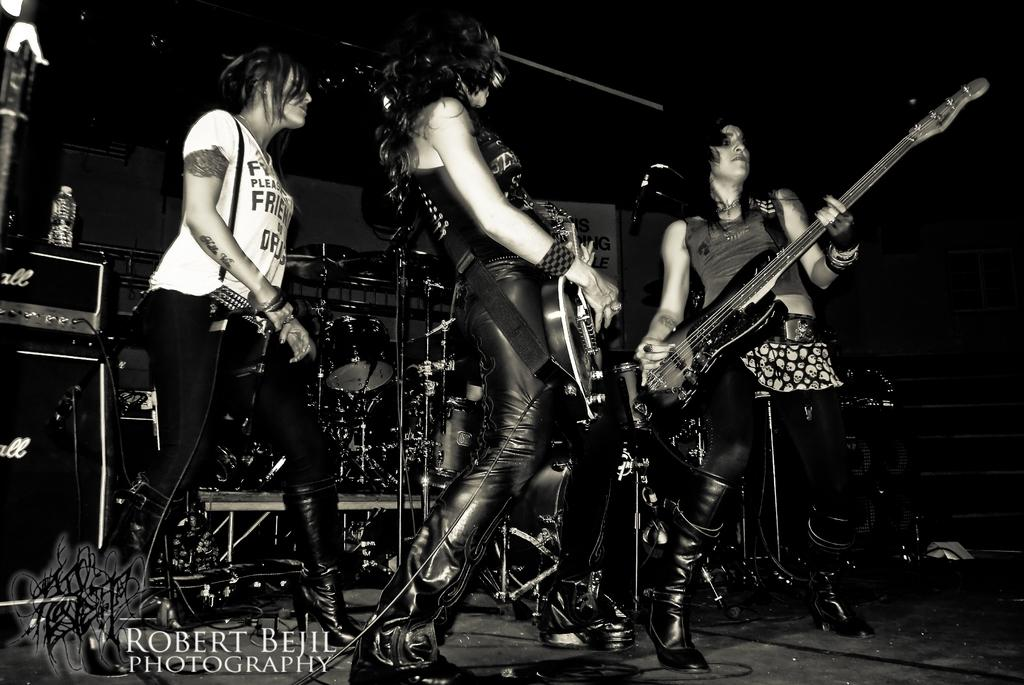How many people are in the image? There are people in the image, but the exact number is not specified. What are the people doing in the image? The people are standing in the image. What objects are the people holding in their hands? The people are holding guitars in their hands. What type of hands can be seen playing the guitars in the image? There is no specific type of hands mentioned or visible in the image; the people are simply holding guitars. Is there an island visible in the background of the image? There is no mention or indication of an island in the image. 